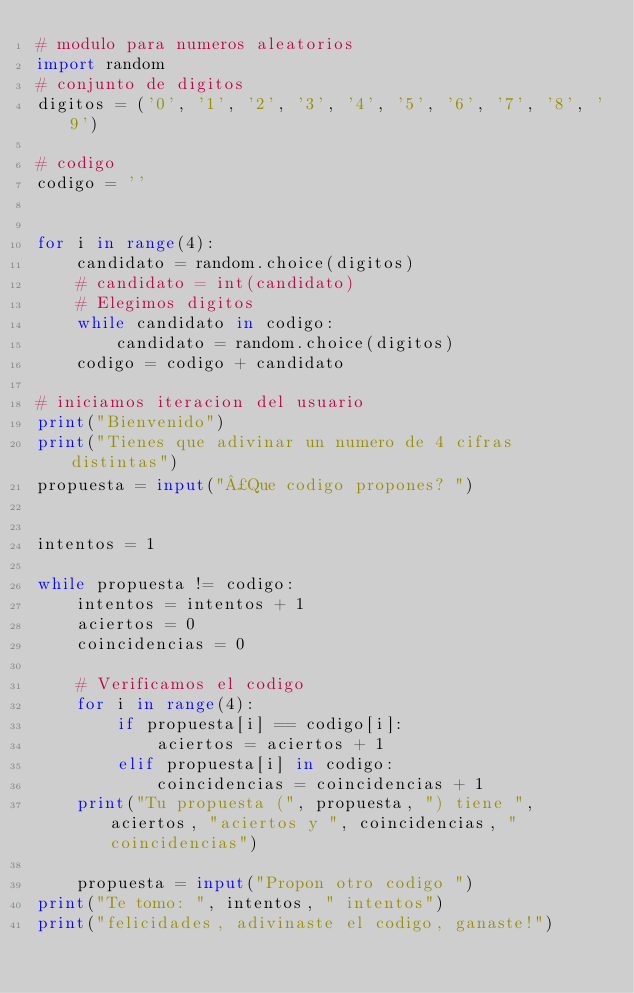Convert code to text. <code><loc_0><loc_0><loc_500><loc_500><_Python_># modulo para numeros aleatorios
import random
# conjunto de digitos
digitos = ('0', '1', '2', '3', '4', '5', '6', '7', '8', '9')

# codigo
codigo = ''


for i in range(4):
    candidato = random.choice(digitos)
    # candidato = int(candidato)
    # Elegimos digitos
    while candidato in codigo:
        candidato = random.choice(digitos)
    codigo = codigo + candidato

# iniciamos iteracion del usuario
print("Bienvenido")
print("Tienes que adivinar un numero de 4 cifras distintas")
propuesta = input("¿Que codigo propones? ")


intentos = 1

while propuesta != codigo:
    intentos = intentos + 1
    aciertos = 0
    coincidencias = 0

    # Verificamos el codigo
    for i in range(4):
        if propuesta[i] == codigo[i]:
            aciertos = aciertos + 1
        elif propuesta[i] in codigo:
            coincidencias = coincidencias + 1
    print("Tu propuesta (", propuesta, ") tiene ", aciertos, "aciertos y ", coincidencias, "coincidencias")

    propuesta = input("Propon otro codigo ")
print("Te tomo: ", intentos, " intentos")
print("felicidades, adivinaste el codigo, ganaste!")</code> 